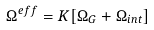Convert formula to latex. <formula><loc_0><loc_0><loc_500><loc_500>\Omega ^ { e f f } = K [ \Omega _ { G } + \Omega _ { i n t } ]</formula> 